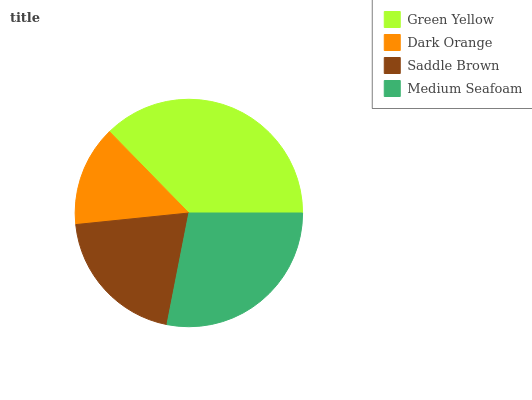Is Dark Orange the minimum?
Answer yes or no. Yes. Is Green Yellow the maximum?
Answer yes or no. Yes. Is Saddle Brown the minimum?
Answer yes or no. No. Is Saddle Brown the maximum?
Answer yes or no. No. Is Saddle Brown greater than Dark Orange?
Answer yes or no. Yes. Is Dark Orange less than Saddle Brown?
Answer yes or no. Yes. Is Dark Orange greater than Saddle Brown?
Answer yes or no. No. Is Saddle Brown less than Dark Orange?
Answer yes or no. No. Is Medium Seafoam the high median?
Answer yes or no. Yes. Is Saddle Brown the low median?
Answer yes or no. Yes. Is Green Yellow the high median?
Answer yes or no. No. Is Green Yellow the low median?
Answer yes or no. No. 